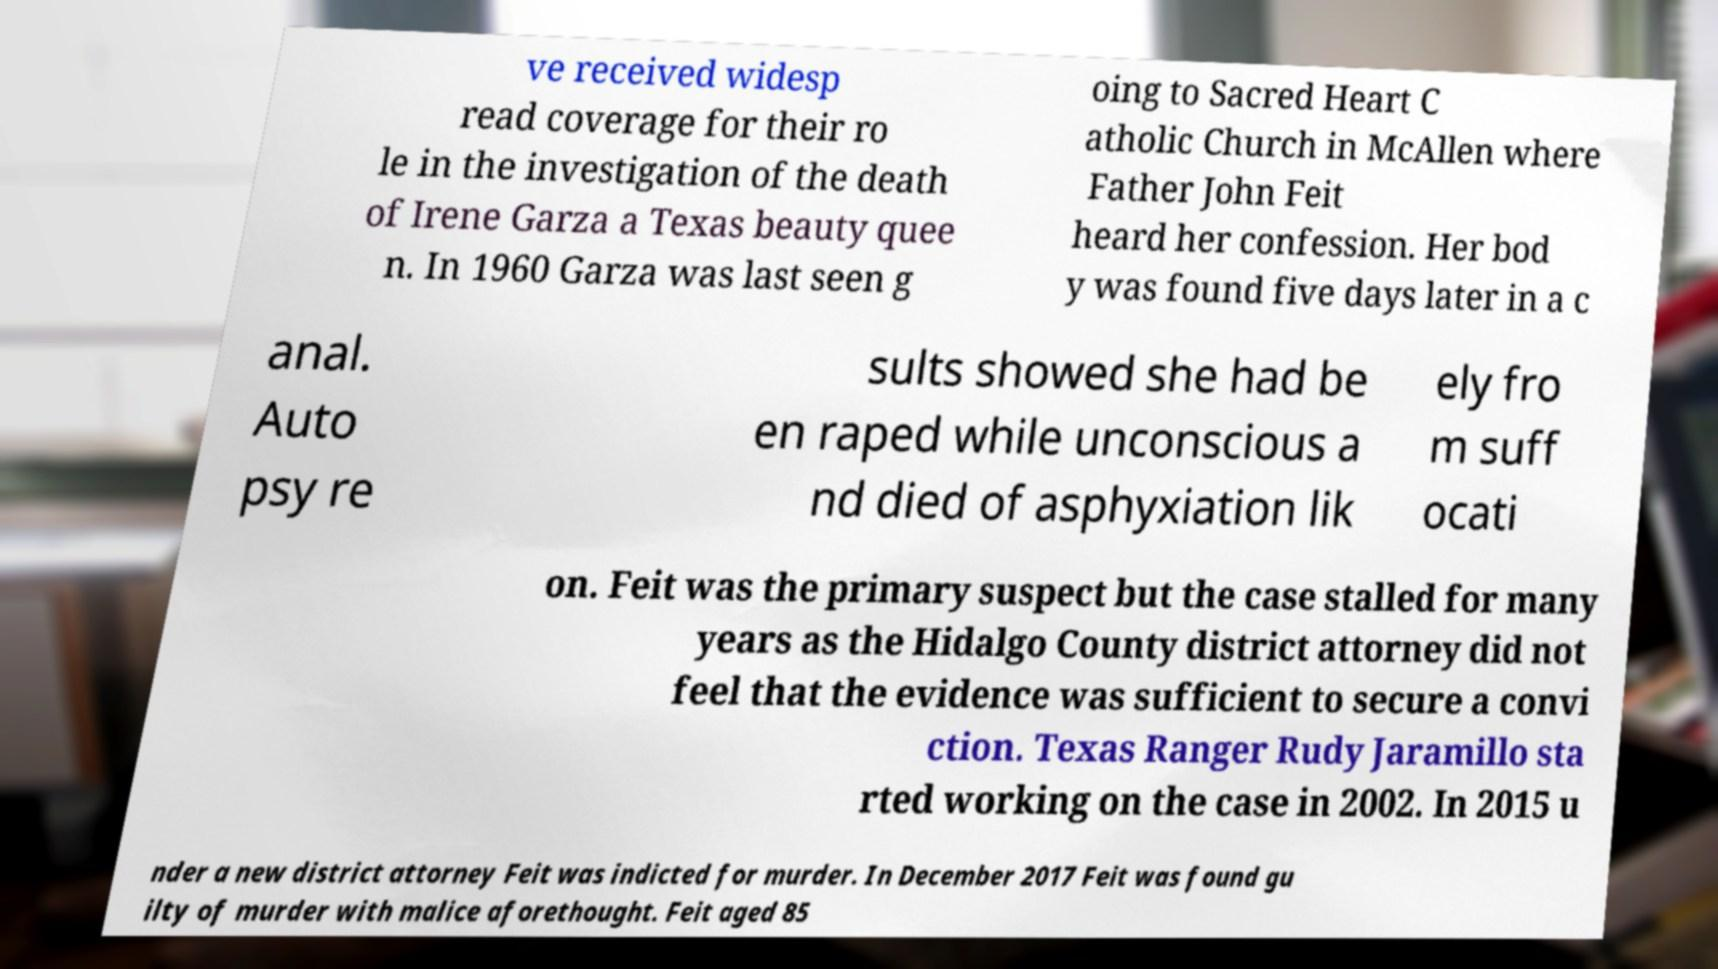What messages or text are displayed in this image? I need them in a readable, typed format. ve received widesp read coverage for their ro le in the investigation of the death of Irene Garza a Texas beauty quee n. In 1960 Garza was last seen g oing to Sacred Heart C atholic Church in McAllen where Father John Feit heard her confession. Her bod y was found five days later in a c anal. Auto psy re sults showed she had be en raped while unconscious a nd died of asphyxiation lik ely fro m suff ocati on. Feit was the primary suspect but the case stalled for many years as the Hidalgo County district attorney did not feel that the evidence was sufficient to secure a convi ction. Texas Ranger Rudy Jaramillo sta rted working on the case in 2002. In 2015 u nder a new district attorney Feit was indicted for murder. In December 2017 Feit was found gu ilty of murder with malice aforethought. Feit aged 85 